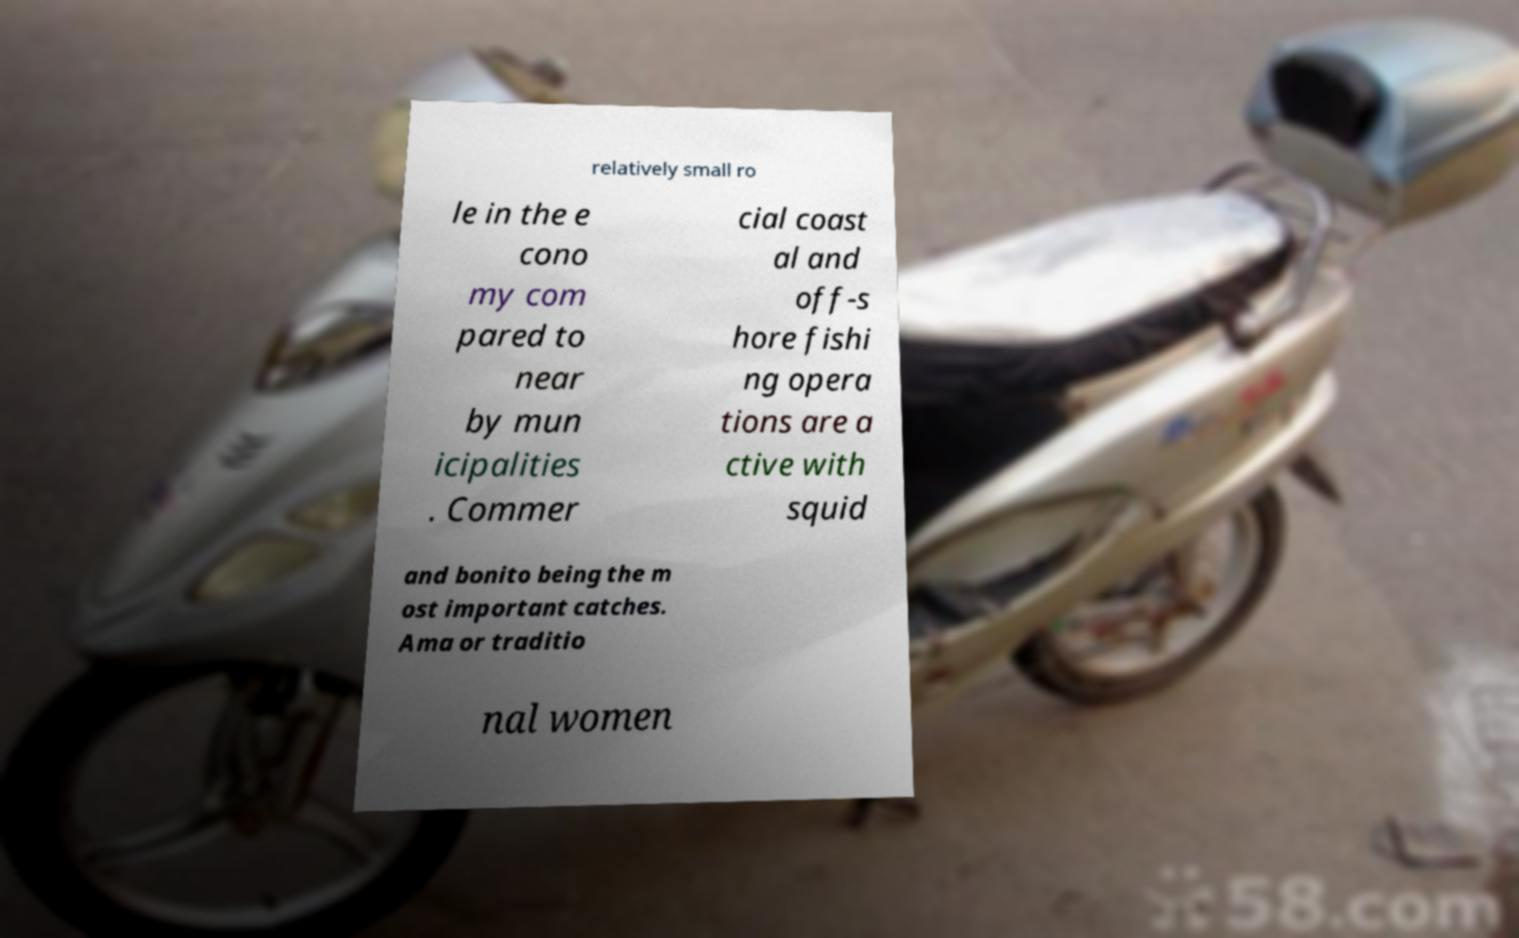For documentation purposes, I need the text within this image transcribed. Could you provide that? relatively small ro le in the e cono my com pared to near by mun icipalities . Commer cial coast al and off-s hore fishi ng opera tions are a ctive with squid and bonito being the m ost important catches. Ama or traditio nal women 